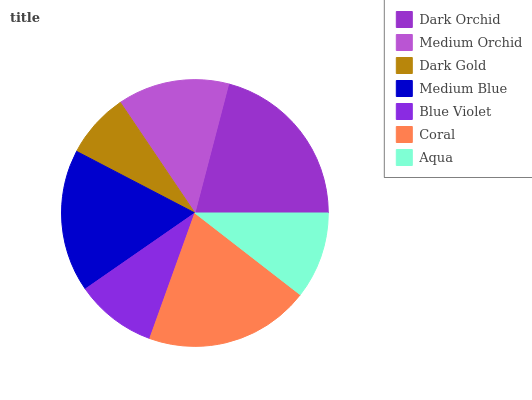Is Dark Gold the minimum?
Answer yes or no. Yes. Is Dark Orchid the maximum?
Answer yes or no. Yes. Is Medium Orchid the minimum?
Answer yes or no. No. Is Medium Orchid the maximum?
Answer yes or no. No. Is Dark Orchid greater than Medium Orchid?
Answer yes or no. Yes. Is Medium Orchid less than Dark Orchid?
Answer yes or no. Yes. Is Medium Orchid greater than Dark Orchid?
Answer yes or no. No. Is Dark Orchid less than Medium Orchid?
Answer yes or no. No. Is Medium Orchid the high median?
Answer yes or no. Yes. Is Medium Orchid the low median?
Answer yes or no. Yes. Is Dark Gold the high median?
Answer yes or no. No. Is Dark Gold the low median?
Answer yes or no. No. 